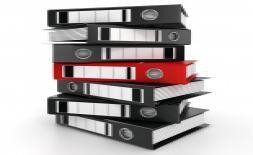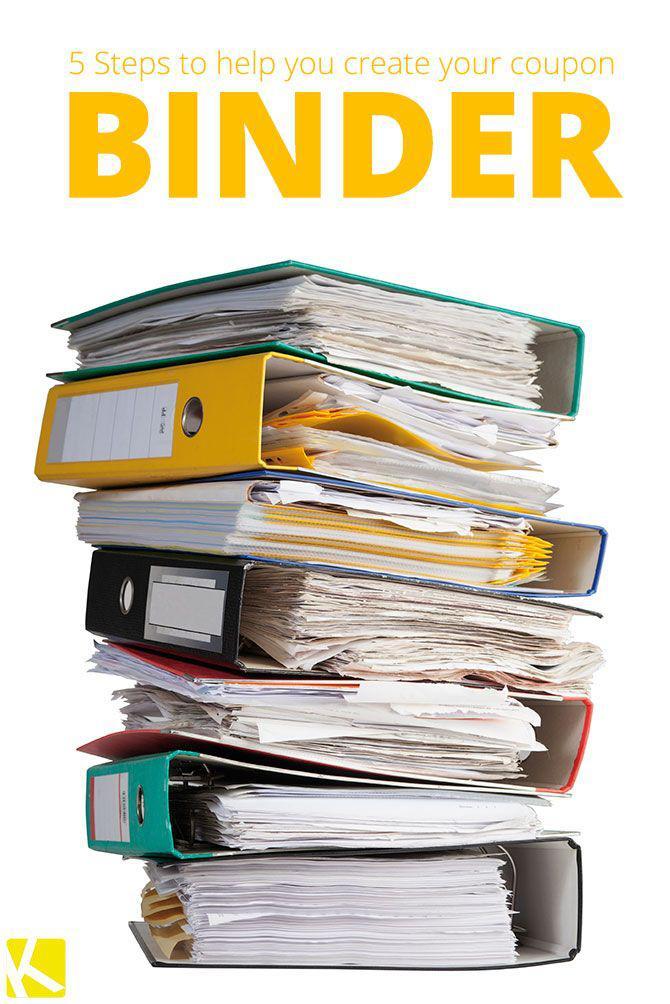The first image is the image on the left, the second image is the image on the right. For the images shown, is this caption "There is a person behind a stack of binders." true? Answer yes or no. No. The first image is the image on the left, the second image is the image on the right. For the images displayed, is the sentence "The right image contains a stack of binders with a person sitting behind it." factually correct? Answer yes or no. No. 